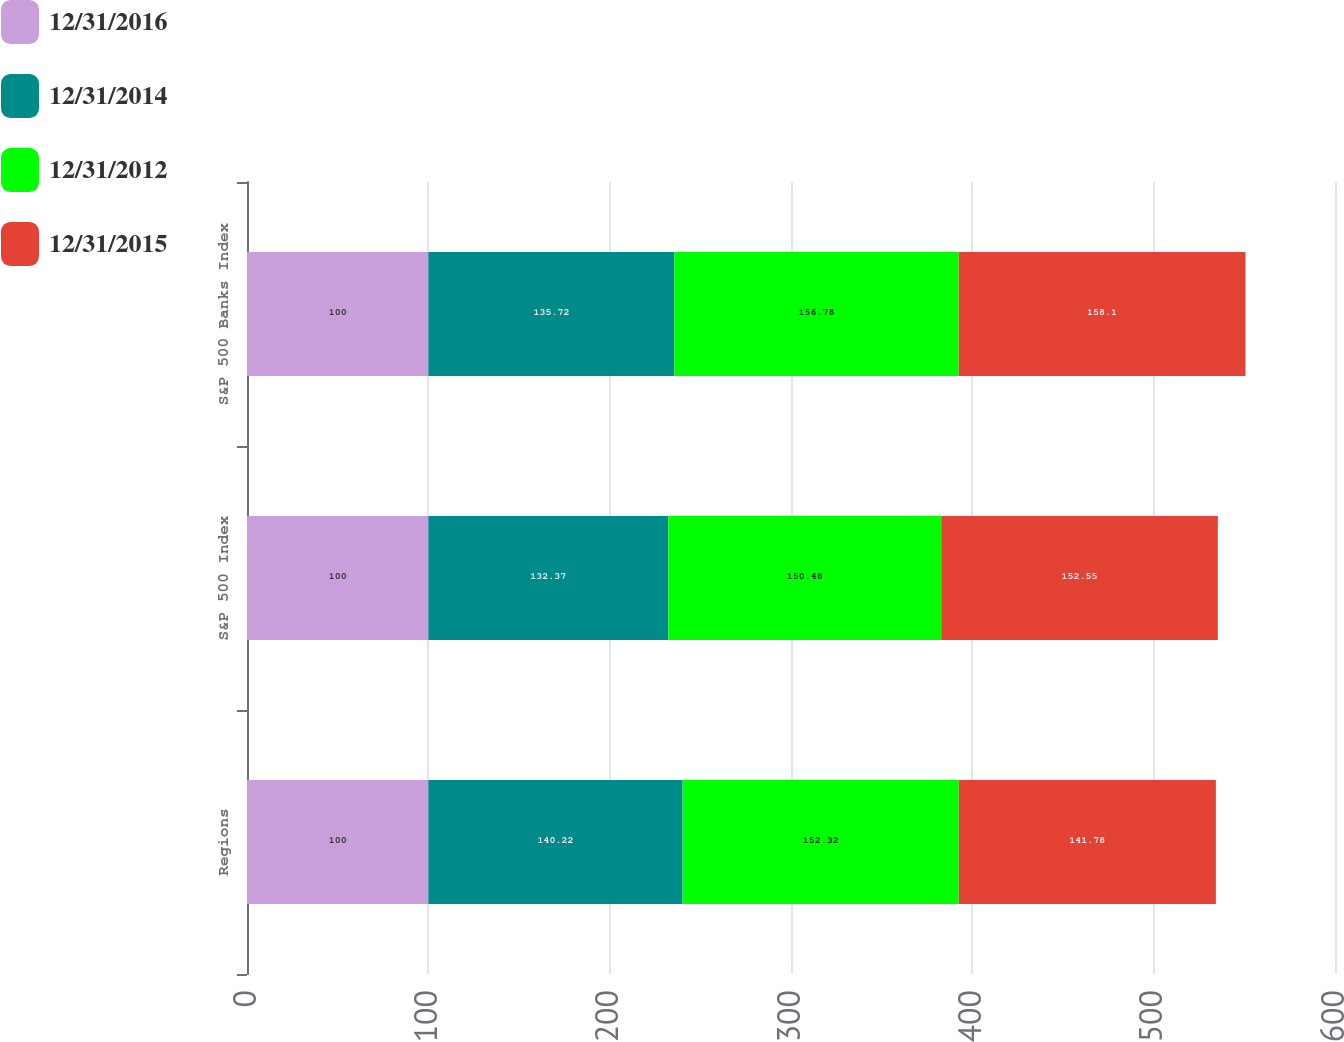Convert chart to OTSL. <chart><loc_0><loc_0><loc_500><loc_500><stacked_bar_chart><ecel><fcel>Regions<fcel>S&P 500 Index<fcel>S&P 500 Banks Index<nl><fcel>12/31/2016<fcel>100<fcel>100<fcel>100<nl><fcel>12/31/2014<fcel>140.22<fcel>132.37<fcel>135.72<nl><fcel>12/31/2012<fcel>152.32<fcel>150.48<fcel>156.78<nl><fcel>12/31/2015<fcel>141.78<fcel>152.55<fcel>158.1<nl></chart> 